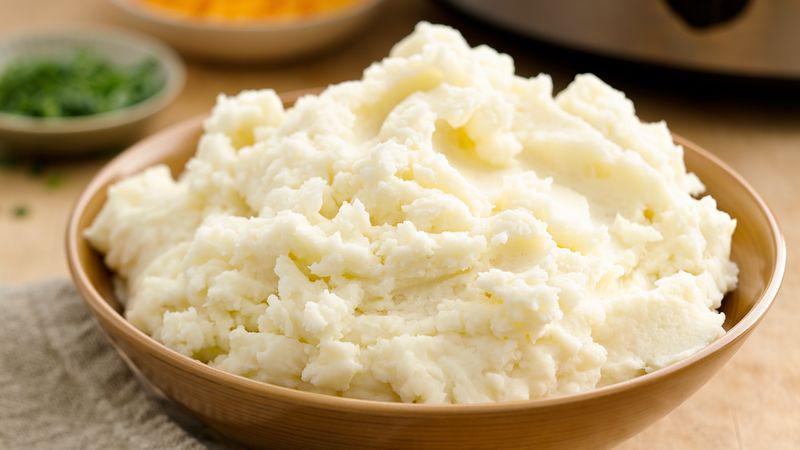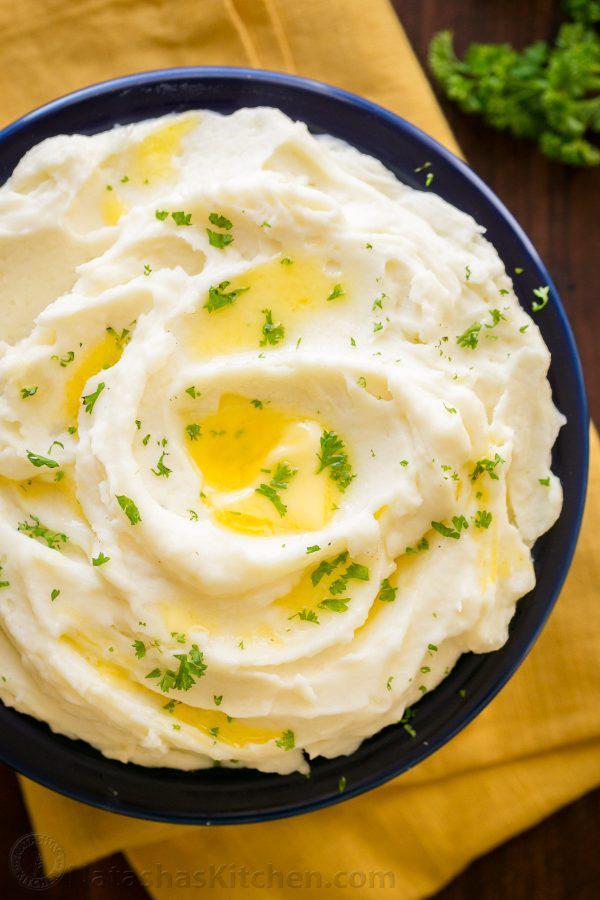The first image is the image on the left, the second image is the image on the right. Considering the images on both sides, is "One of the mashed potato dishes is squared, with four sides." valid? Answer yes or no. No. 